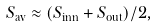Convert formula to latex. <formula><loc_0><loc_0><loc_500><loc_500>S _ { \text {av} } \approx ( S _ { \text {inn} } + S _ { \text {out} } ) / { 2 } ,</formula> 